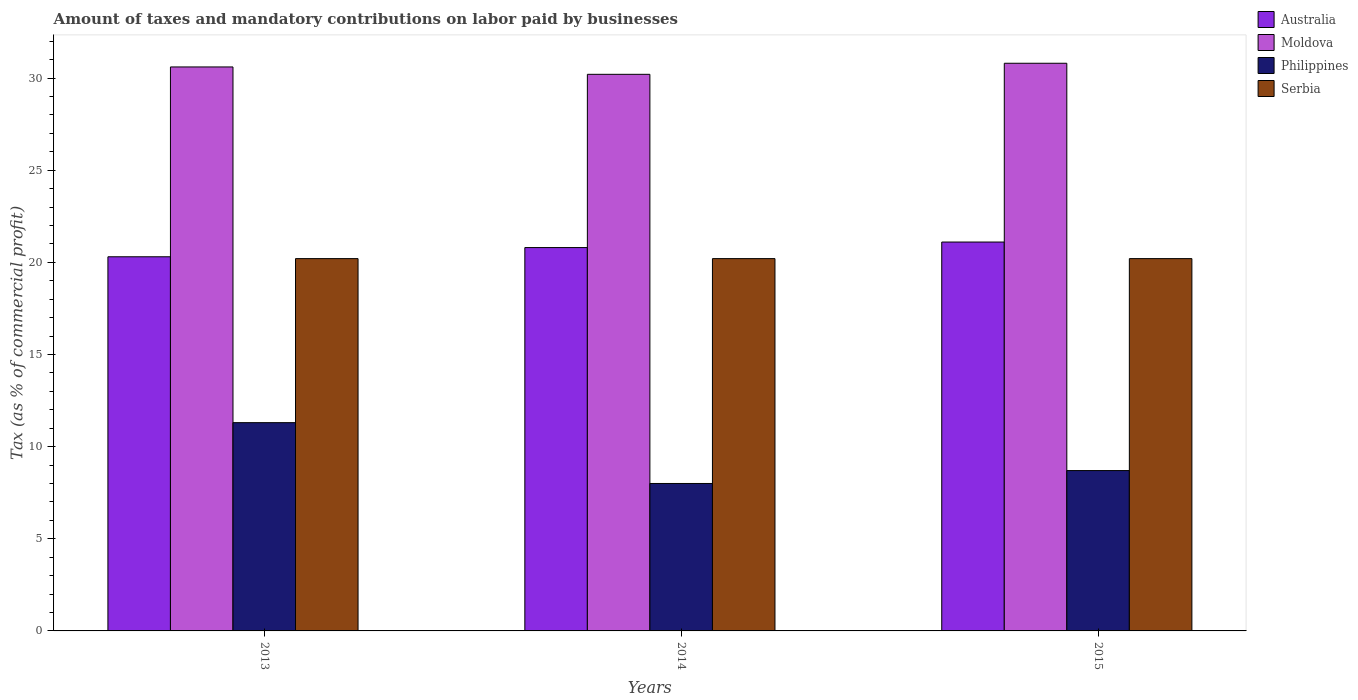How many different coloured bars are there?
Provide a succinct answer. 4. Are the number of bars on each tick of the X-axis equal?
Your answer should be very brief. Yes. How many bars are there on the 3rd tick from the left?
Give a very brief answer. 4. How many bars are there on the 3rd tick from the right?
Provide a succinct answer. 4. In how many cases, is the number of bars for a given year not equal to the number of legend labels?
Give a very brief answer. 0. Across all years, what is the maximum percentage of taxes paid by businesses in Moldova?
Your answer should be very brief. 30.8. What is the total percentage of taxes paid by businesses in Philippines in the graph?
Provide a short and direct response. 28. What is the difference between the percentage of taxes paid by businesses in Moldova in 2014 and that in 2015?
Ensure brevity in your answer.  -0.6. What is the difference between the percentage of taxes paid by businesses in Philippines in 2015 and the percentage of taxes paid by businesses in Moldova in 2014?
Ensure brevity in your answer.  -21.5. What is the average percentage of taxes paid by businesses in Australia per year?
Your response must be concise. 20.73. In the year 2013, what is the difference between the percentage of taxes paid by businesses in Serbia and percentage of taxes paid by businesses in Philippines?
Give a very brief answer. 8.9. In how many years, is the percentage of taxes paid by businesses in Moldova greater than 20 %?
Offer a very short reply. 3. What is the ratio of the percentage of taxes paid by businesses in Moldova in 2013 to that in 2015?
Give a very brief answer. 0.99. Is the percentage of taxes paid by businesses in Australia in 2013 less than that in 2015?
Provide a succinct answer. Yes. Is the difference between the percentage of taxes paid by businesses in Serbia in 2013 and 2015 greater than the difference between the percentage of taxes paid by businesses in Philippines in 2013 and 2015?
Your answer should be very brief. No. What is the difference between the highest and the second highest percentage of taxes paid by businesses in Philippines?
Offer a terse response. 2.6. What is the difference between the highest and the lowest percentage of taxes paid by businesses in Australia?
Make the answer very short. 0.8. In how many years, is the percentage of taxes paid by businesses in Serbia greater than the average percentage of taxes paid by businesses in Serbia taken over all years?
Ensure brevity in your answer.  0. Is the sum of the percentage of taxes paid by businesses in Moldova in 2014 and 2015 greater than the maximum percentage of taxes paid by businesses in Australia across all years?
Your response must be concise. Yes. Is it the case that in every year, the sum of the percentage of taxes paid by businesses in Australia and percentage of taxes paid by businesses in Philippines is greater than the sum of percentage of taxes paid by businesses in Moldova and percentage of taxes paid by businesses in Serbia?
Give a very brief answer. Yes. What does the 4th bar from the right in 2013 represents?
Offer a terse response. Australia. Is it the case that in every year, the sum of the percentage of taxes paid by businesses in Moldova and percentage of taxes paid by businesses in Serbia is greater than the percentage of taxes paid by businesses in Australia?
Your answer should be compact. Yes. How many bars are there?
Your answer should be compact. 12. What is the difference between two consecutive major ticks on the Y-axis?
Keep it short and to the point. 5. Does the graph contain any zero values?
Provide a short and direct response. No. Does the graph contain grids?
Give a very brief answer. No. Where does the legend appear in the graph?
Provide a short and direct response. Top right. How are the legend labels stacked?
Offer a terse response. Vertical. What is the title of the graph?
Your answer should be very brief. Amount of taxes and mandatory contributions on labor paid by businesses. Does "Jamaica" appear as one of the legend labels in the graph?
Your response must be concise. No. What is the label or title of the X-axis?
Offer a very short reply. Years. What is the label or title of the Y-axis?
Offer a very short reply. Tax (as % of commercial profit). What is the Tax (as % of commercial profit) of Australia in 2013?
Ensure brevity in your answer.  20.3. What is the Tax (as % of commercial profit) of Moldova in 2013?
Ensure brevity in your answer.  30.6. What is the Tax (as % of commercial profit) in Serbia in 2013?
Provide a short and direct response. 20.2. What is the Tax (as % of commercial profit) of Australia in 2014?
Your answer should be compact. 20.8. What is the Tax (as % of commercial profit) of Moldova in 2014?
Your response must be concise. 30.2. What is the Tax (as % of commercial profit) in Serbia in 2014?
Provide a succinct answer. 20.2. What is the Tax (as % of commercial profit) of Australia in 2015?
Give a very brief answer. 21.1. What is the Tax (as % of commercial profit) in Moldova in 2015?
Keep it short and to the point. 30.8. What is the Tax (as % of commercial profit) in Philippines in 2015?
Offer a very short reply. 8.7. What is the Tax (as % of commercial profit) of Serbia in 2015?
Make the answer very short. 20.2. Across all years, what is the maximum Tax (as % of commercial profit) in Australia?
Your answer should be compact. 21.1. Across all years, what is the maximum Tax (as % of commercial profit) in Moldova?
Offer a terse response. 30.8. Across all years, what is the maximum Tax (as % of commercial profit) in Philippines?
Provide a succinct answer. 11.3. Across all years, what is the maximum Tax (as % of commercial profit) of Serbia?
Your answer should be compact. 20.2. Across all years, what is the minimum Tax (as % of commercial profit) of Australia?
Offer a very short reply. 20.3. Across all years, what is the minimum Tax (as % of commercial profit) in Moldova?
Your answer should be compact. 30.2. Across all years, what is the minimum Tax (as % of commercial profit) of Serbia?
Your answer should be very brief. 20.2. What is the total Tax (as % of commercial profit) of Australia in the graph?
Give a very brief answer. 62.2. What is the total Tax (as % of commercial profit) in Moldova in the graph?
Offer a terse response. 91.6. What is the total Tax (as % of commercial profit) of Serbia in the graph?
Provide a succinct answer. 60.6. What is the difference between the Tax (as % of commercial profit) of Moldova in 2013 and that in 2014?
Offer a terse response. 0.4. What is the difference between the Tax (as % of commercial profit) of Philippines in 2013 and that in 2014?
Keep it short and to the point. 3.3. What is the difference between the Tax (as % of commercial profit) of Serbia in 2013 and that in 2014?
Ensure brevity in your answer.  0. What is the difference between the Tax (as % of commercial profit) of Australia in 2013 and that in 2015?
Ensure brevity in your answer.  -0.8. What is the difference between the Tax (as % of commercial profit) of Moldova in 2013 and that in 2015?
Make the answer very short. -0.2. What is the difference between the Tax (as % of commercial profit) of Australia in 2014 and that in 2015?
Make the answer very short. -0.3. What is the difference between the Tax (as % of commercial profit) of Moldova in 2014 and that in 2015?
Your answer should be compact. -0.6. What is the difference between the Tax (as % of commercial profit) in Australia in 2013 and the Tax (as % of commercial profit) in Philippines in 2014?
Make the answer very short. 12.3. What is the difference between the Tax (as % of commercial profit) of Moldova in 2013 and the Tax (as % of commercial profit) of Philippines in 2014?
Ensure brevity in your answer.  22.6. What is the difference between the Tax (as % of commercial profit) in Australia in 2013 and the Tax (as % of commercial profit) in Moldova in 2015?
Make the answer very short. -10.5. What is the difference between the Tax (as % of commercial profit) of Australia in 2013 and the Tax (as % of commercial profit) of Philippines in 2015?
Your answer should be compact. 11.6. What is the difference between the Tax (as % of commercial profit) of Moldova in 2013 and the Tax (as % of commercial profit) of Philippines in 2015?
Offer a very short reply. 21.9. What is the difference between the Tax (as % of commercial profit) of Moldova in 2013 and the Tax (as % of commercial profit) of Serbia in 2015?
Make the answer very short. 10.4. What is the difference between the Tax (as % of commercial profit) of Philippines in 2013 and the Tax (as % of commercial profit) of Serbia in 2015?
Your answer should be very brief. -8.9. What is the difference between the Tax (as % of commercial profit) of Moldova in 2014 and the Tax (as % of commercial profit) of Philippines in 2015?
Give a very brief answer. 21.5. What is the difference between the Tax (as % of commercial profit) of Moldova in 2014 and the Tax (as % of commercial profit) of Serbia in 2015?
Ensure brevity in your answer.  10. What is the difference between the Tax (as % of commercial profit) in Philippines in 2014 and the Tax (as % of commercial profit) in Serbia in 2015?
Make the answer very short. -12.2. What is the average Tax (as % of commercial profit) in Australia per year?
Ensure brevity in your answer.  20.73. What is the average Tax (as % of commercial profit) in Moldova per year?
Keep it short and to the point. 30.53. What is the average Tax (as % of commercial profit) of Philippines per year?
Your response must be concise. 9.33. What is the average Tax (as % of commercial profit) in Serbia per year?
Keep it short and to the point. 20.2. In the year 2013, what is the difference between the Tax (as % of commercial profit) of Australia and Tax (as % of commercial profit) of Moldova?
Your answer should be very brief. -10.3. In the year 2013, what is the difference between the Tax (as % of commercial profit) of Australia and Tax (as % of commercial profit) of Philippines?
Your answer should be very brief. 9. In the year 2013, what is the difference between the Tax (as % of commercial profit) of Australia and Tax (as % of commercial profit) of Serbia?
Your response must be concise. 0.1. In the year 2013, what is the difference between the Tax (as % of commercial profit) in Moldova and Tax (as % of commercial profit) in Philippines?
Provide a succinct answer. 19.3. In the year 2013, what is the difference between the Tax (as % of commercial profit) of Moldova and Tax (as % of commercial profit) of Serbia?
Your response must be concise. 10.4. In the year 2013, what is the difference between the Tax (as % of commercial profit) in Philippines and Tax (as % of commercial profit) in Serbia?
Your answer should be very brief. -8.9. In the year 2014, what is the difference between the Tax (as % of commercial profit) in Australia and Tax (as % of commercial profit) in Philippines?
Provide a short and direct response. 12.8. In the year 2014, what is the difference between the Tax (as % of commercial profit) in Australia and Tax (as % of commercial profit) in Serbia?
Make the answer very short. 0.6. In the year 2014, what is the difference between the Tax (as % of commercial profit) of Moldova and Tax (as % of commercial profit) of Serbia?
Provide a succinct answer. 10. In the year 2015, what is the difference between the Tax (as % of commercial profit) of Moldova and Tax (as % of commercial profit) of Philippines?
Offer a terse response. 22.1. In the year 2015, what is the difference between the Tax (as % of commercial profit) in Moldova and Tax (as % of commercial profit) in Serbia?
Provide a short and direct response. 10.6. In the year 2015, what is the difference between the Tax (as % of commercial profit) of Philippines and Tax (as % of commercial profit) of Serbia?
Keep it short and to the point. -11.5. What is the ratio of the Tax (as % of commercial profit) of Australia in 2013 to that in 2014?
Ensure brevity in your answer.  0.98. What is the ratio of the Tax (as % of commercial profit) of Moldova in 2013 to that in 2014?
Your response must be concise. 1.01. What is the ratio of the Tax (as % of commercial profit) in Philippines in 2013 to that in 2014?
Offer a very short reply. 1.41. What is the ratio of the Tax (as % of commercial profit) in Serbia in 2013 to that in 2014?
Offer a very short reply. 1. What is the ratio of the Tax (as % of commercial profit) of Australia in 2013 to that in 2015?
Ensure brevity in your answer.  0.96. What is the ratio of the Tax (as % of commercial profit) of Moldova in 2013 to that in 2015?
Your answer should be compact. 0.99. What is the ratio of the Tax (as % of commercial profit) in Philippines in 2013 to that in 2015?
Your response must be concise. 1.3. What is the ratio of the Tax (as % of commercial profit) in Serbia in 2013 to that in 2015?
Offer a terse response. 1. What is the ratio of the Tax (as % of commercial profit) of Australia in 2014 to that in 2015?
Offer a terse response. 0.99. What is the ratio of the Tax (as % of commercial profit) in Moldova in 2014 to that in 2015?
Your response must be concise. 0.98. What is the ratio of the Tax (as % of commercial profit) in Philippines in 2014 to that in 2015?
Keep it short and to the point. 0.92. What is the ratio of the Tax (as % of commercial profit) in Serbia in 2014 to that in 2015?
Give a very brief answer. 1. What is the difference between the highest and the second highest Tax (as % of commercial profit) in Australia?
Your answer should be very brief. 0.3. What is the difference between the highest and the second highest Tax (as % of commercial profit) of Moldova?
Ensure brevity in your answer.  0.2. What is the difference between the highest and the second highest Tax (as % of commercial profit) of Serbia?
Give a very brief answer. 0. What is the difference between the highest and the lowest Tax (as % of commercial profit) in Moldova?
Make the answer very short. 0.6. What is the difference between the highest and the lowest Tax (as % of commercial profit) in Serbia?
Your answer should be compact. 0. 